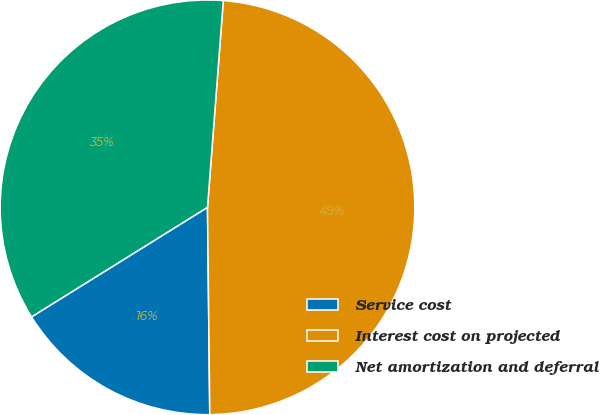Convert chart to OTSL. <chart><loc_0><loc_0><loc_500><loc_500><pie_chart><fcel>Service cost<fcel>Interest cost on projected<fcel>Net amortization and deferral<nl><fcel>16.31%<fcel>48.61%<fcel>35.08%<nl></chart> 